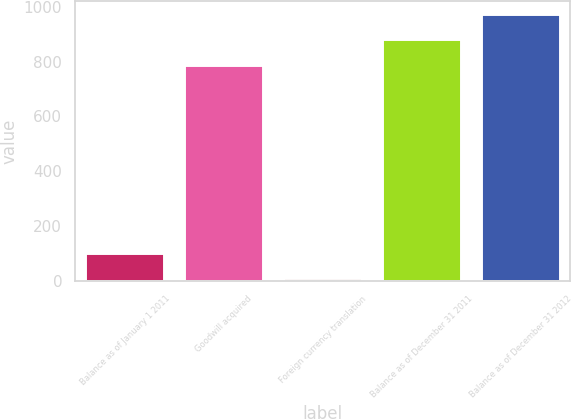Convert chart to OTSL. <chart><loc_0><loc_0><loc_500><loc_500><bar_chart><fcel>Balance as of January 1 2011<fcel>Goodwill acquired<fcel>Foreign currency translation<fcel>Balance as of December 31 2011<fcel>Balance as of December 31 2012<nl><fcel>103.7<fcel>788<fcel>11<fcel>880.7<fcel>973.4<nl></chart> 